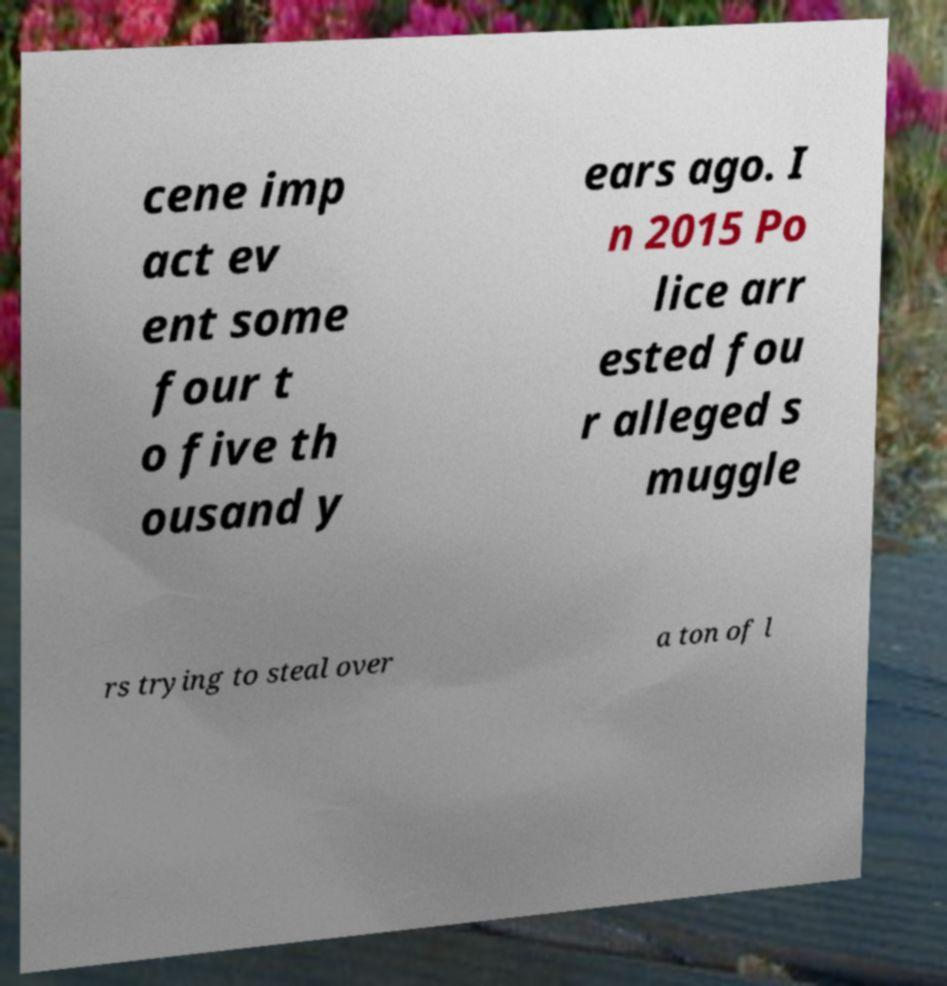I need the written content from this picture converted into text. Can you do that? cene imp act ev ent some four t o five th ousand y ears ago. I n 2015 Po lice arr ested fou r alleged s muggle rs trying to steal over a ton of l 